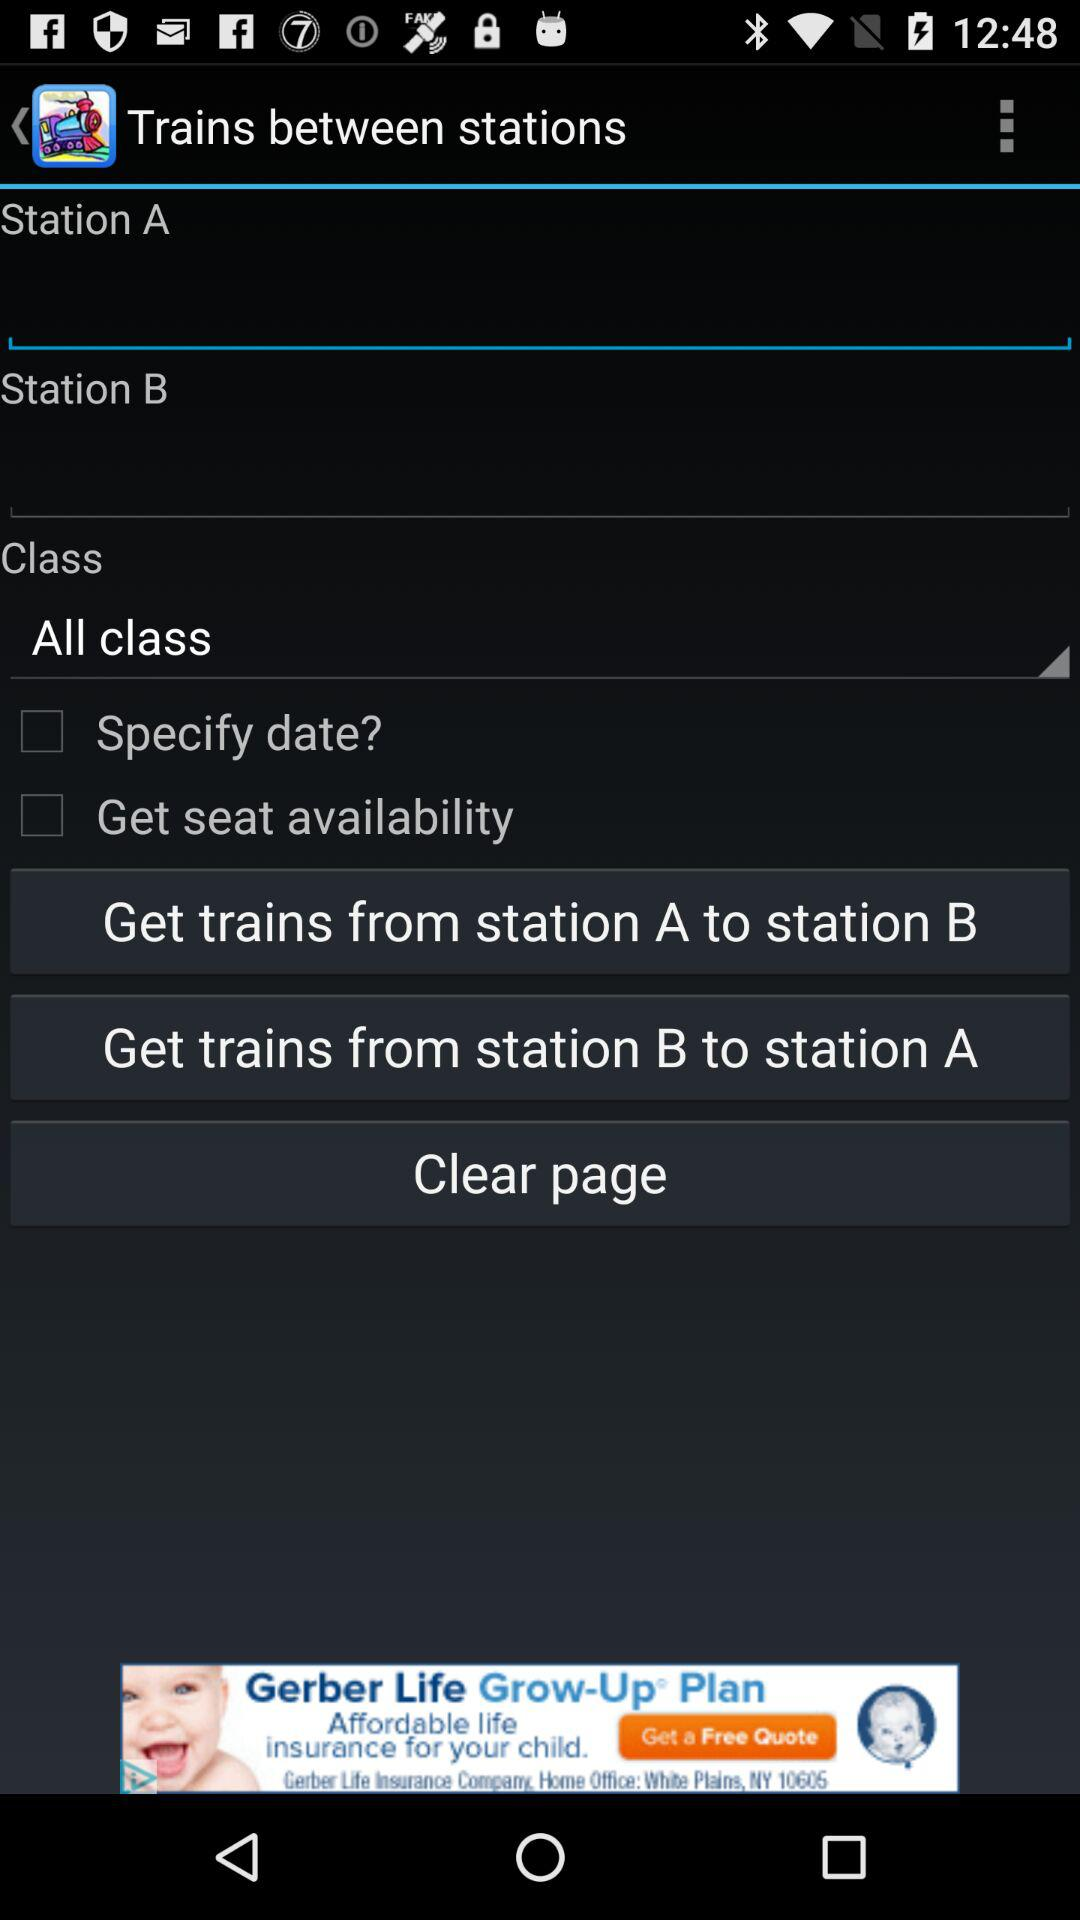What is the status of "Specify date"? The status is off. 